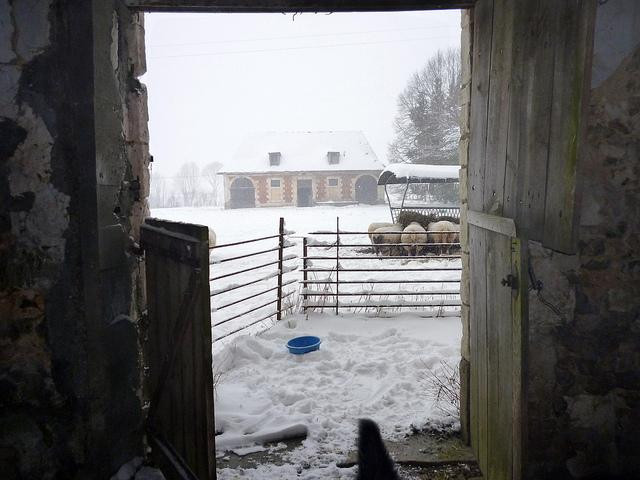From what kind of building was this picture taken? Please explain your reasoning. barn. There is a large wooden door and gates in front of it 